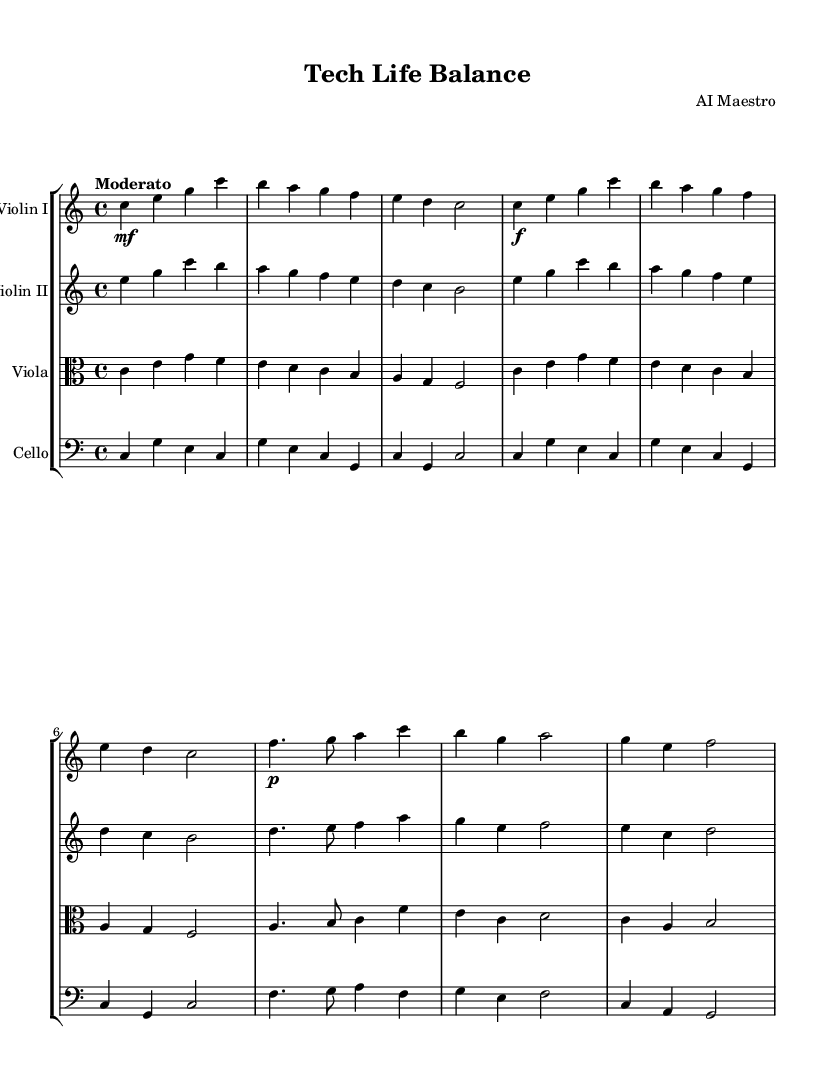What is the key signature of this music? The key signature is C major, which has no sharps or flats indicated at the beginning of the staff.
Answer: C major What is the time signature of the piece? The time signature is indicated as 4/4, meaning there are four beats in each measure and a quarter note receives one beat.
Answer: 4/4 What is the tempo marking for this symphony? The tempo marking is "Moderato," suggesting a moderate pace for the performance of this piece.
Answer: Moderato How many themes are present in this symphony? There are two themes identified in the music: Theme A (Work) and Theme B (Personal Life), which are labeled at specific sections of the score.
Answer: Two Which instrument plays the highest notes in the introduction? The highest notes in the introduction are played by the Violin I, as it plays the initial melody.
Answer: Violin I Which section represents the personal life theme? The section representing the personal life theme is Theme B, which is characterized by the use of softer dynamics and a more lyrical quality, showcasing contrast with Theme A.
Answer: Theme B 